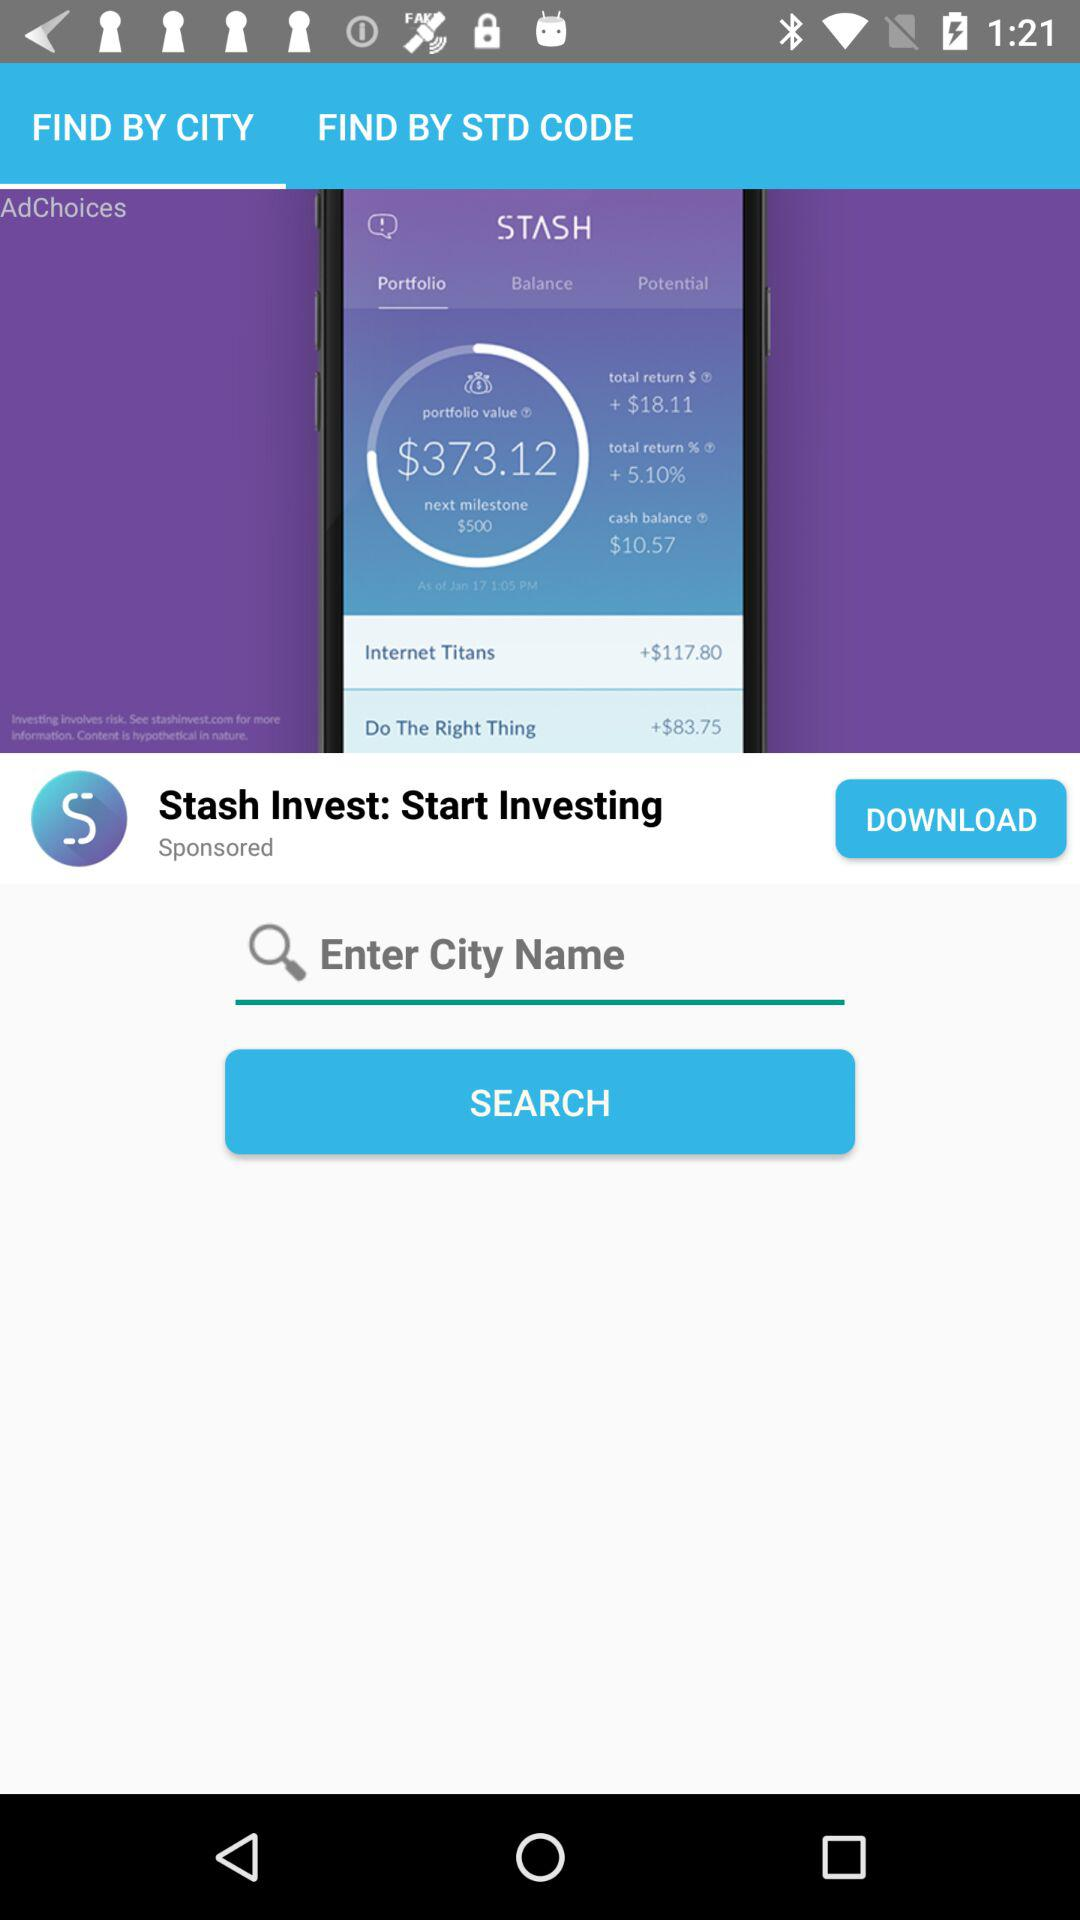Which tab is selected? The selected tab is "FIND BY CITY". 